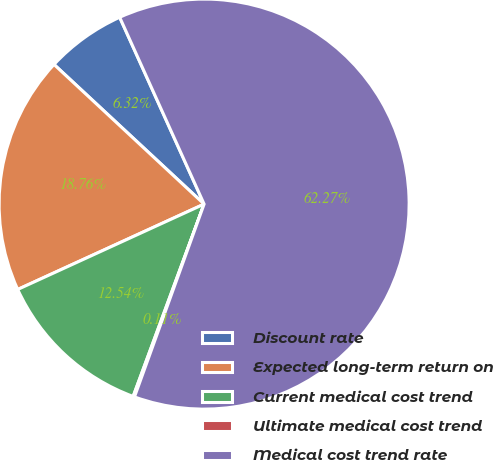Convert chart. <chart><loc_0><loc_0><loc_500><loc_500><pie_chart><fcel>Discount rate<fcel>Expected long-term return on<fcel>Current medical cost trend<fcel>Ultimate medical cost trend<fcel>Medical cost trend rate<nl><fcel>6.32%<fcel>18.76%<fcel>12.54%<fcel>0.11%<fcel>62.27%<nl></chart> 